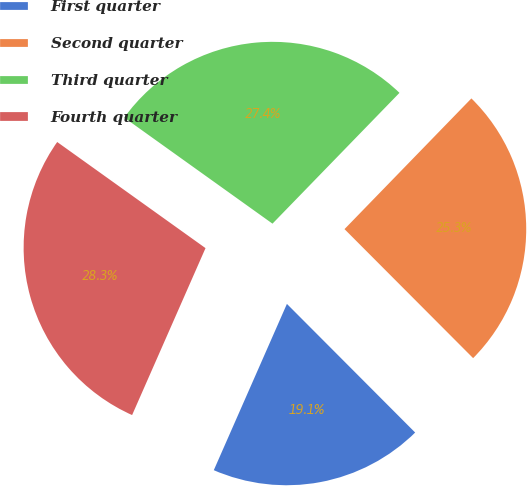<chart> <loc_0><loc_0><loc_500><loc_500><pie_chart><fcel>First quarter<fcel>Second quarter<fcel>Third quarter<fcel>Fourth quarter<nl><fcel>19.07%<fcel>25.26%<fcel>27.38%<fcel>28.29%<nl></chart> 